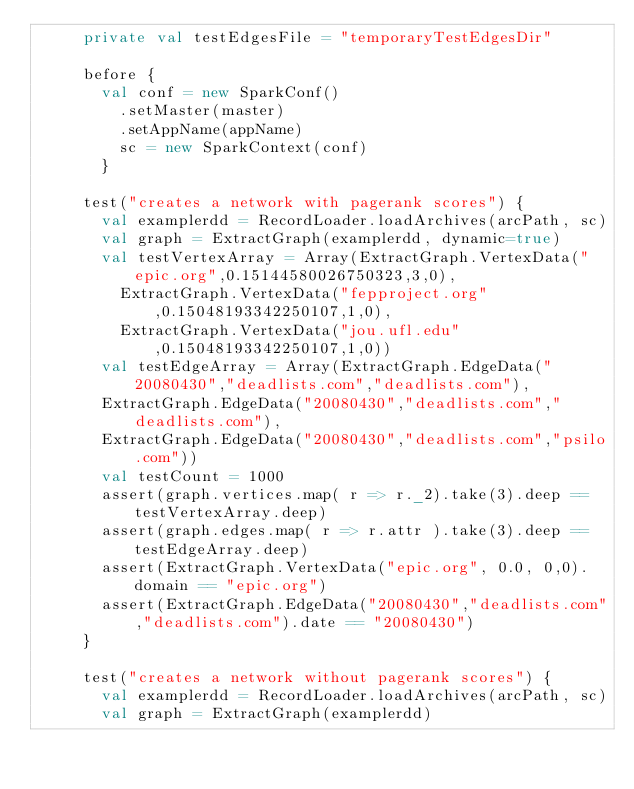Convert code to text. <code><loc_0><loc_0><loc_500><loc_500><_Scala_>     private val testEdgesFile = "temporaryTestEdgesDir"

     before {
       val conf = new SparkConf()
         .setMaster(master)
         .setAppName(appName)
         sc = new SparkContext(conf)
       }

     test("creates a network with pagerank scores") {
       val examplerdd = RecordLoader.loadArchives(arcPath, sc)
       val graph = ExtractGraph(examplerdd, dynamic=true)
       val testVertexArray = Array(ExtractGraph.VertexData("epic.org",0.15144580026750323,3,0),
         ExtractGraph.VertexData("fepproject.org",0.15048193342250107,1,0),
         ExtractGraph.VertexData("jou.ufl.edu",0.15048193342250107,1,0))
       val testEdgeArray = Array(ExtractGraph.EdgeData("20080430","deadlists.com","deadlists.com"),
       ExtractGraph.EdgeData("20080430","deadlists.com","deadlists.com"),
       ExtractGraph.EdgeData("20080430","deadlists.com","psilo.com"))
       val testCount = 1000
       assert(graph.vertices.map( r => r._2).take(3).deep == testVertexArray.deep)
       assert(graph.edges.map( r => r.attr ).take(3).deep == testEdgeArray.deep)
       assert(ExtractGraph.VertexData("epic.org", 0.0, 0,0).domain == "epic.org")
       assert(ExtractGraph.EdgeData("20080430","deadlists.com","deadlists.com").date == "20080430")
     }

     test("creates a network without pagerank scores") {
       val examplerdd = RecordLoader.loadArchives(arcPath, sc)
       val graph = ExtractGraph(examplerdd)</code> 